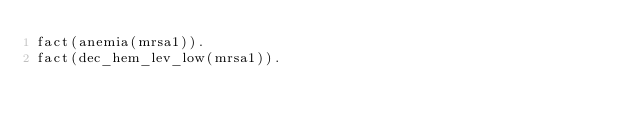<code> <loc_0><loc_0><loc_500><loc_500><_Perl_>fact(anemia(mrsa1)).
fact(dec_hem_lev_low(mrsa1)).
</code> 